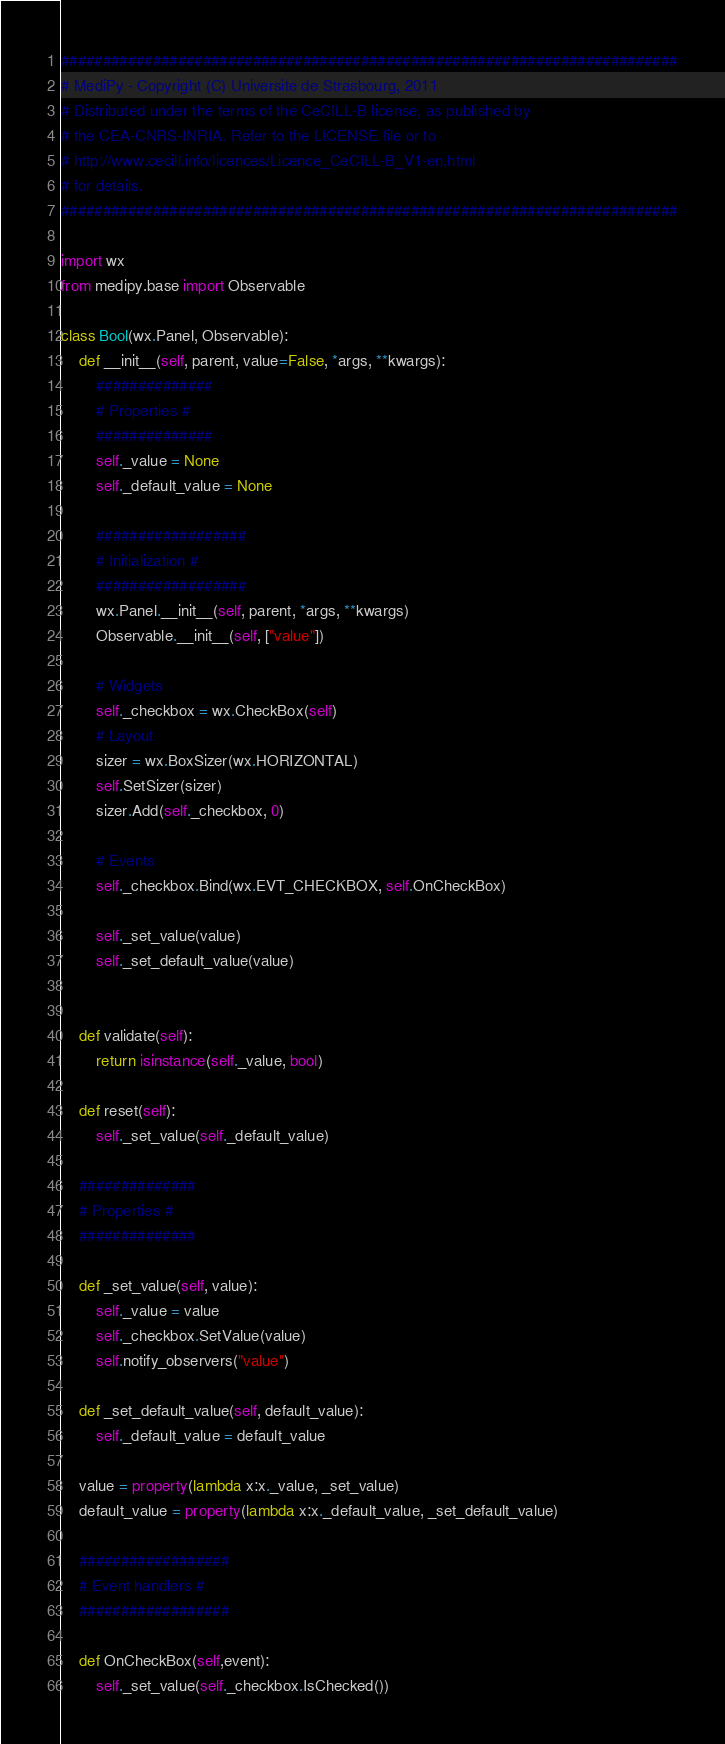Convert code to text. <code><loc_0><loc_0><loc_500><loc_500><_Python_>##########################################################################
# MediPy - Copyright (C) Universite de Strasbourg, 2011             
# Distributed under the terms of the CeCILL-B license, as published by 
# the CEA-CNRS-INRIA. Refer to the LICENSE file or to            
# http://www.cecill.info/licences/Licence_CeCILL-B_V1-en.html       
# for details.                                                      
##########################################################################

import wx
from medipy.base import Observable

class Bool(wx.Panel, Observable):
    def __init__(self, parent, value=False, *args, **kwargs):
        ##############
        # Properties #
        ##############
        self._value = None
        self._default_value = None
        
        ##################
        # Initialization #
        ##################
        wx.Panel.__init__(self, parent, *args, **kwargs)
        Observable.__init__(self, ["value"])
        
        # Widgets
        self._checkbox = wx.CheckBox(self)
        # Layout
        sizer = wx.BoxSizer(wx.HORIZONTAL)
        self.SetSizer(sizer)
        sizer.Add(self._checkbox, 0)
        
        # Events
        self._checkbox.Bind(wx.EVT_CHECKBOX, self.OnCheckBox)
        
        self._set_value(value)
        self._set_default_value(value)
    
    
    def validate(self):
        return isinstance(self._value, bool)
    
    def reset(self):
        self._set_value(self._default_value)
    
    ##############
    # Properties #
    ##############
    
    def _set_value(self, value):
        self._value = value
        self._checkbox.SetValue(value)
        self.notify_observers("value")
    
    def _set_default_value(self, default_value):
        self._default_value = default_value
    
    value = property(lambda x:x._value, _set_value)
    default_value = property(lambda x:x._default_value, _set_default_value)
    
    ##################
    # Event handlers #
    ##################
    
    def OnCheckBox(self,event):
        self._set_value(self._checkbox.IsChecked())
</code> 